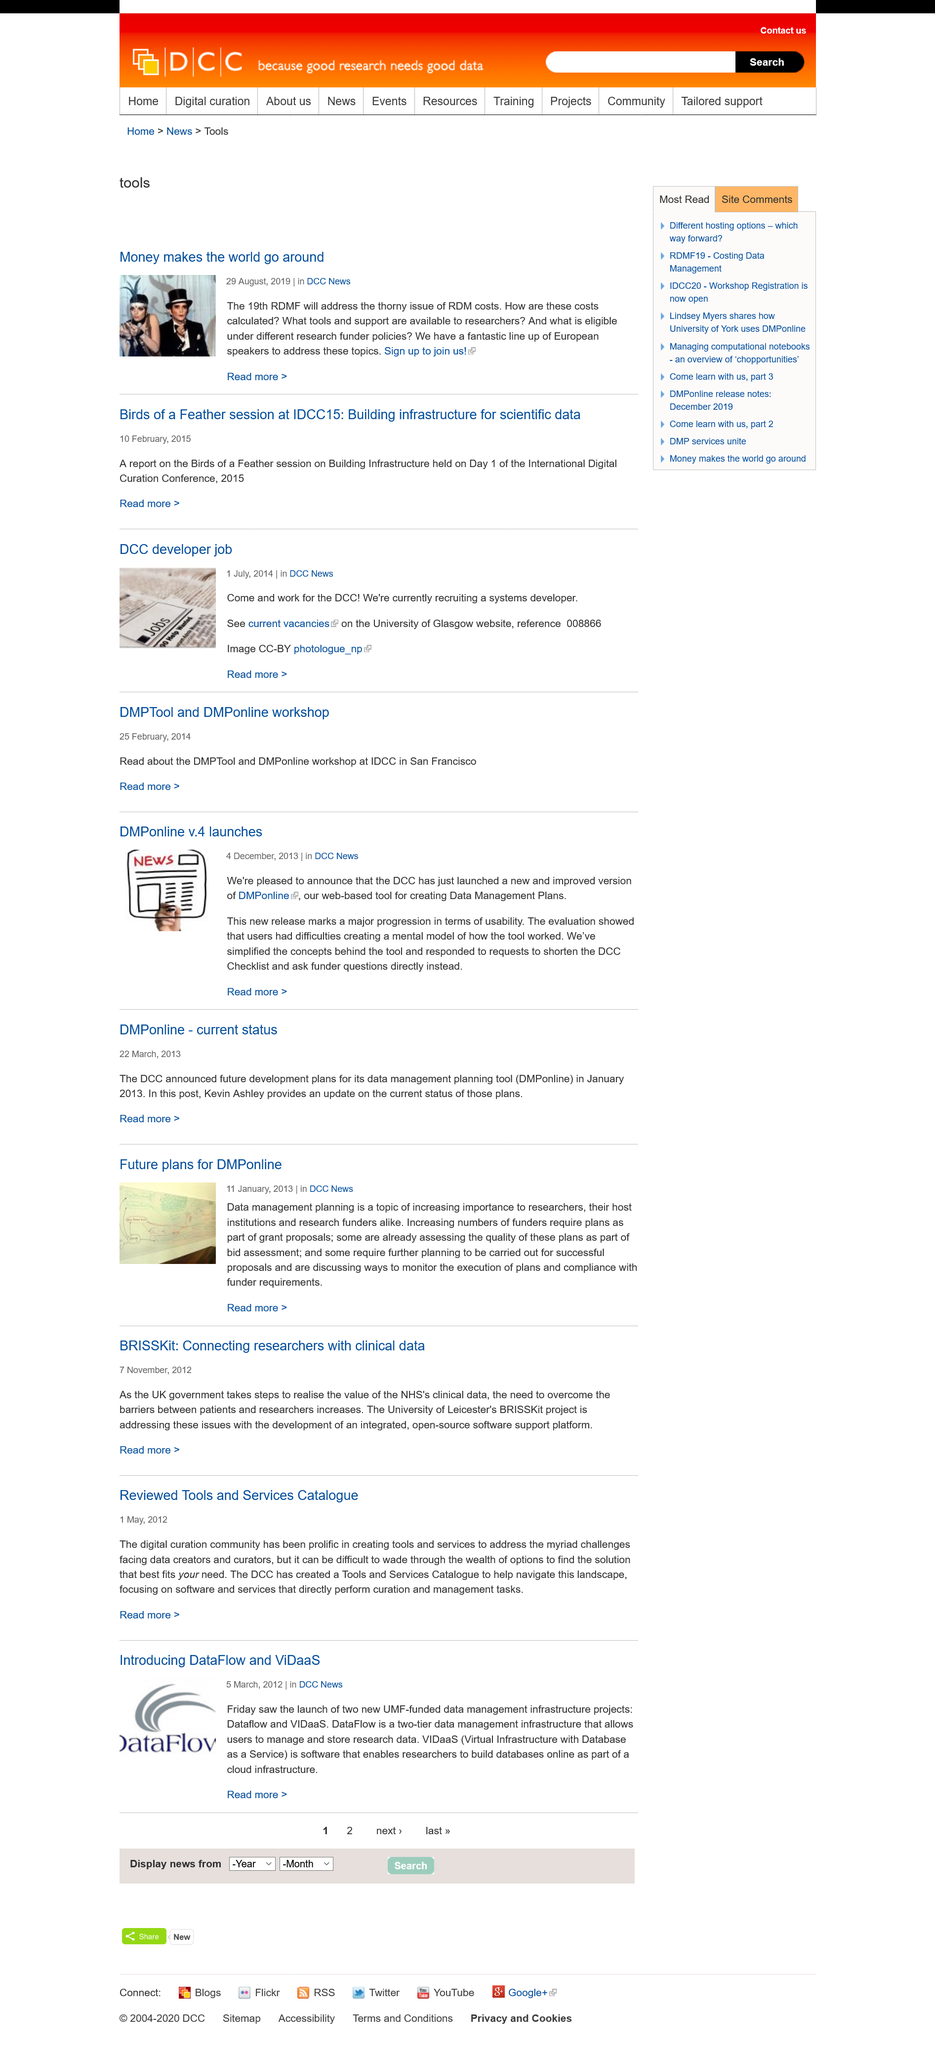List a handful of essential elements in this visual. The article on BRISSKit was published on 7 November, 2012, as stated in the article. The DCC has created a Tools and Services Catalogue. The article on reviewed tools and services catalogue was published on May 1, 2012. 